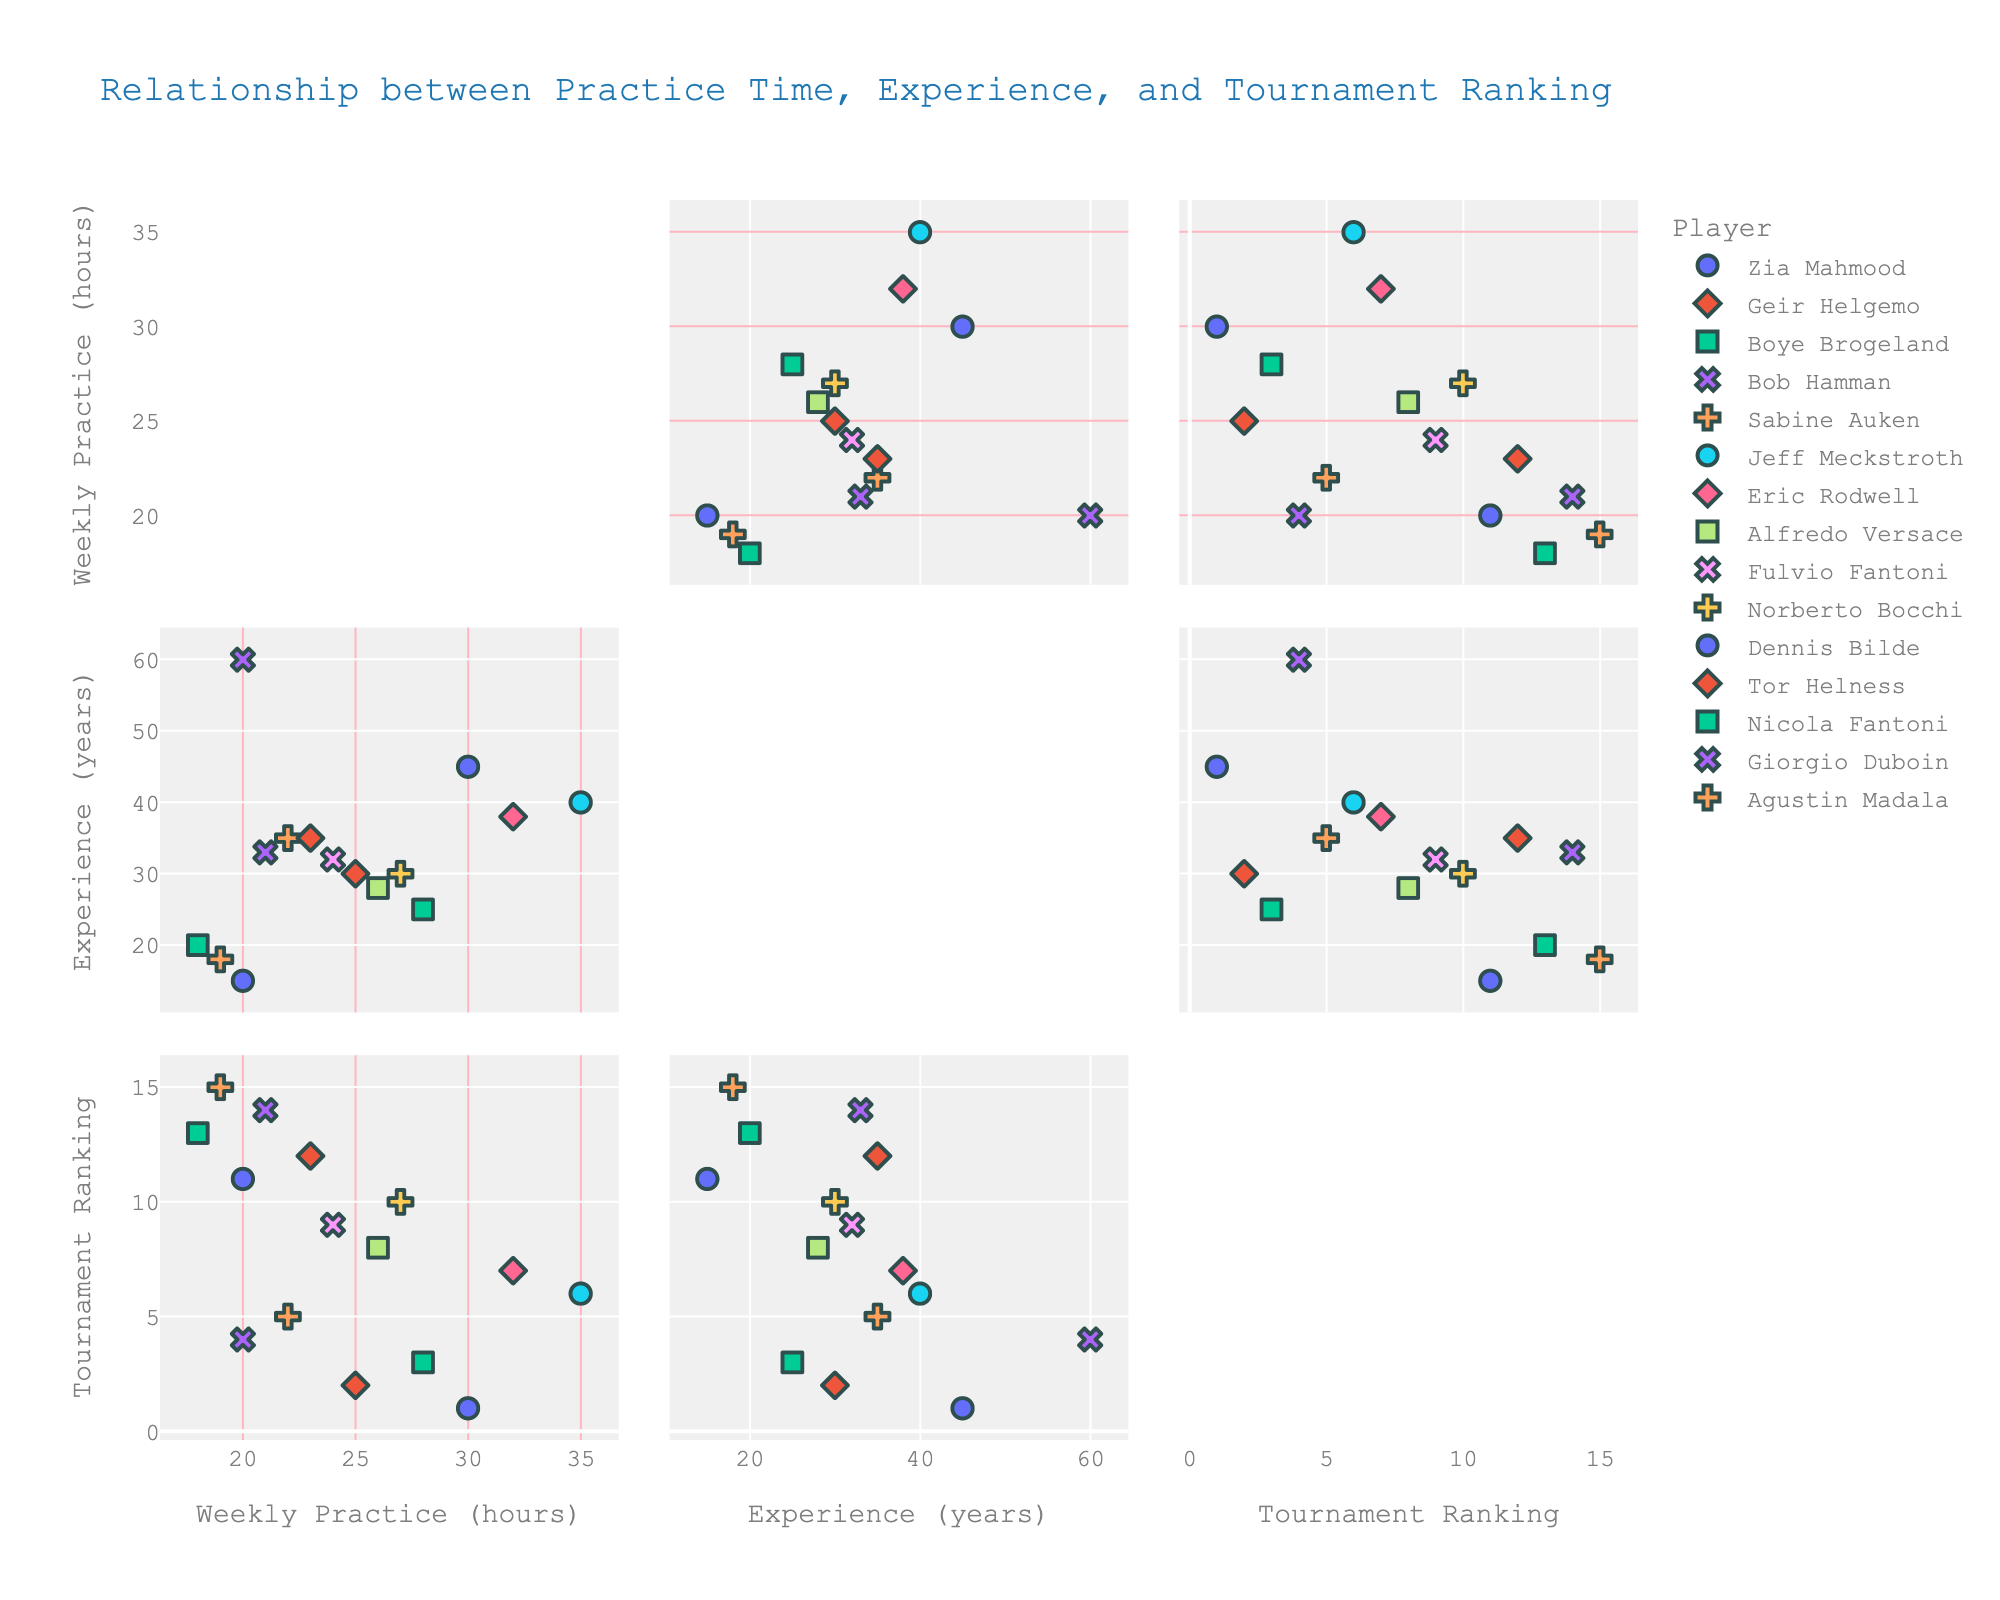What is the title of the figure? The title of the figure is displayed at the top and reads "Relationship between Practice Time, Experience, and Tournament Ranking".
Answer: Relationship between Practice Time, Experience, and Tournament Ranking How many data points are shown in the scatterplot matrix? Each player in the dataset corresponds to a single data point. There are 15 players listed, hence 15 data points are present.
Answer: 15 Which player has the most weekly practice hours? Check the "Weekly Practice (hours)" axis and identify the player associated with the highest value. Jeff Meckstroth has the highest value of 35 hours.
Answer: Jeff Meckstroth What is the color of the markers representing "Eric Rodwell"? Examine the color legend or the marker uniquely associated with "Eric Rodwell". The color for Eric Rodwell is displayed in the legend.
Answer: (Color Name/Appearance, e.g., Blue, Red, etc.) Which player has the most years of experience? Check the "Experience (years)" axis and identify the player associated with the highest value, which is Bob Hamman with 60 years of experience.
Answer: Bob Hamman Which players appear to have similar weekly practice hours? Look for players whose markers align horizontally on the "Weekly Practice (hours)" axis, such as Norberto Bocchi (27) and Boye Brogeland (28) who have close practice hours.
Answer: Norberto Bocchi, Boye Brogeland Who has the highest tournament ranking, and what are their practice hours and years of experience? Identify the player with the lowest value on the "Tournament Ranking" axis, which corresponds to rank 1. Zia Mahmood has a ranking of 1 with 30 practice hours and 45 years of experience.
Answer: Zia Mahmood, 30 practice hours, 45 years of experience Compare the practice hours for Dennis Bilde and Sabine Auken. Who practices more? Locate the markers for Dennis Bilde and Sabine Auken on the "Weekly Practice (hours)" axis. Sabine Auken practices 22 hours weekly, while Dennis Bilde practices 20. Thus, Sabine Auken practices more.
Answer: Sabine Auken Is there a general trend between years of experience and tournament ranking? By studying the "Experience (years)" and "Tournament Ranking" scatterplots, observe if players with more experience tend to have better (lower) rankings. There is a rough trend that more experienced players have lower (better) rankings.
Answer: More experienced players tend to have better rankings 